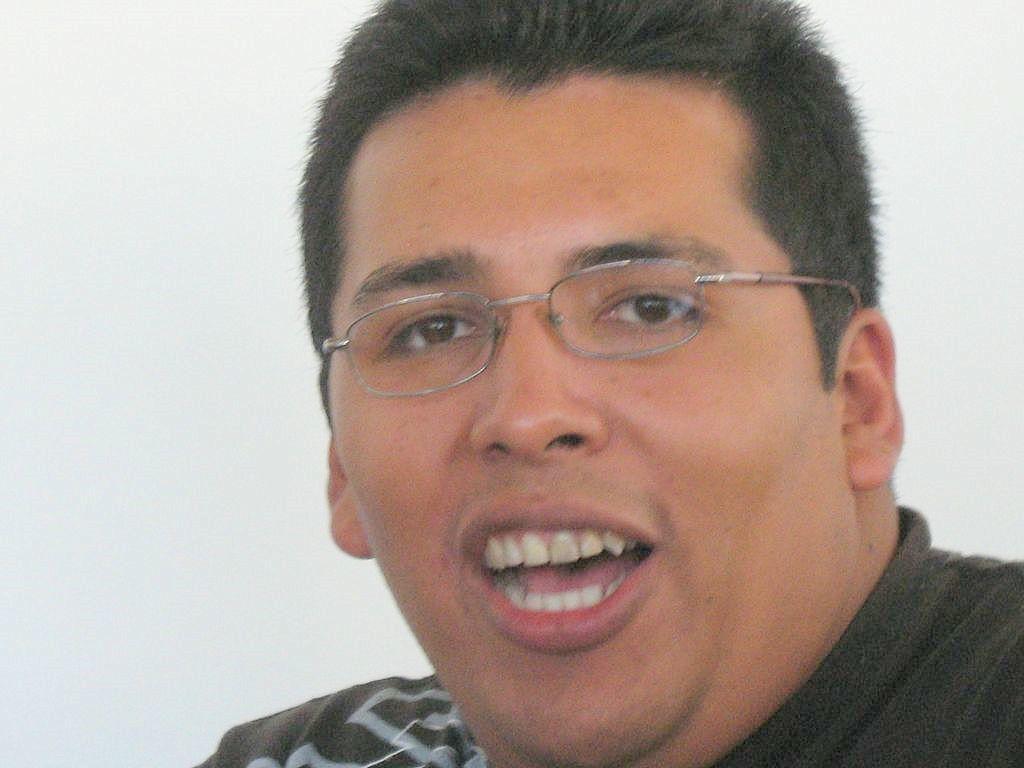Describe this image in one or two sentences. The picture consists of a person, he is wearing spectacles and talking something. In the background it is white. 